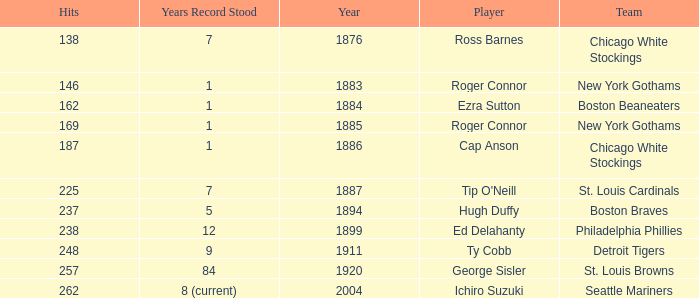Name the least hits for year less than 1920 and player of ed delahanty 238.0. 